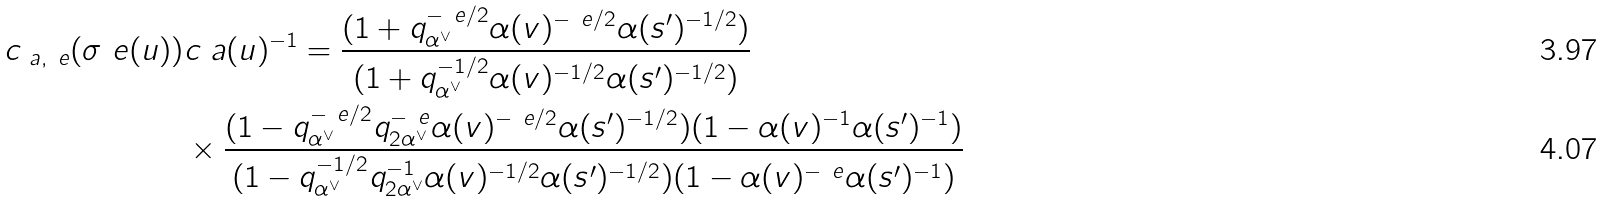<formula> <loc_0><loc_0><loc_500><loc_500>c _ { \ a , \ e } ( \sigma _ { \ } e ( u ) ) & c _ { \ } a ( u ) ^ { - 1 } = \frac { ( 1 + q _ { \alpha ^ { \vee } } ^ { - \ e / 2 } \alpha ( v ) ^ { - \ e / 2 } \alpha ( s ^ { \prime } ) ^ { - 1 / 2 } ) } { ( 1 + q _ { \alpha ^ { \vee } } ^ { - 1 / 2 } \alpha ( v ) ^ { - 1 / 2 } \alpha ( s ^ { \prime } ) ^ { - 1 / 2 } ) } \\ & \times \frac { ( 1 - q _ { \alpha ^ { \vee } } ^ { - \ e / 2 } q _ { 2 \alpha ^ { \vee } } ^ { - \ e } \alpha ( v ) ^ { - \ e / 2 } \alpha ( s ^ { \prime } ) ^ { - 1 / 2 } ) ( 1 - \alpha ( v ) ^ { - 1 } \alpha ( s ^ { \prime } ) ^ { - 1 } ) } { ( 1 - q _ { \alpha ^ { \vee } } ^ { - 1 / 2 } q _ { 2 \alpha ^ { \vee } } ^ { - 1 } \alpha ( v ) ^ { - 1 / 2 } \alpha ( s ^ { \prime } ) ^ { - 1 / 2 } ) ( 1 - \alpha ( v ) ^ { - \ e } \alpha ( s ^ { \prime } ) ^ { - 1 } ) }</formula> 